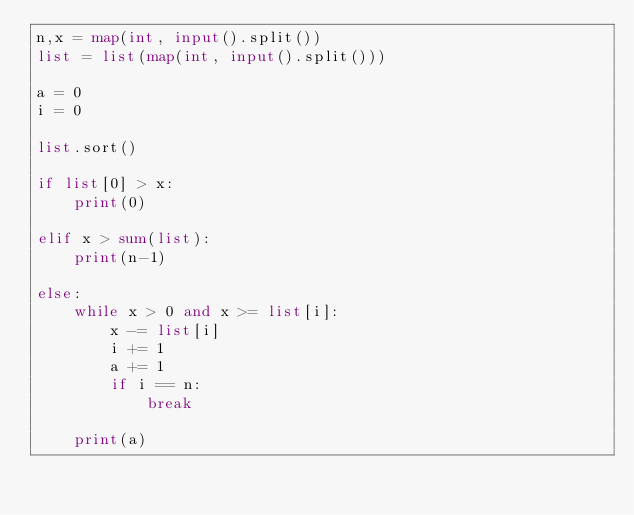Convert code to text. <code><loc_0><loc_0><loc_500><loc_500><_Python_>n,x = map(int, input().split())
list = list(map(int, input().split()))

a = 0
i = 0

list.sort()

if list[0] > x:
    print(0)

elif x > sum(list):
    print(n-1)

else:
    while x > 0 and x >= list[i]:
        x -= list[i]
        i += 1
        a += 1
        if i == n:
            break

    print(a)</code> 